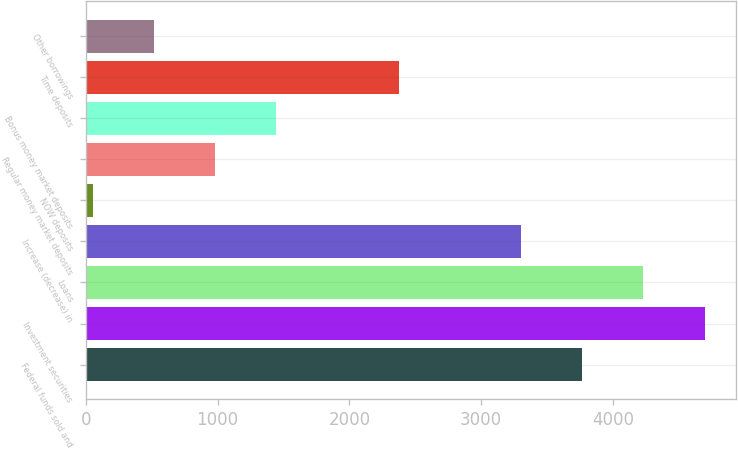Convert chart. <chart><loc_0><loc_0><loc_500><loc_500><bar_chart><fcel>Federal funds sold and<fcel>Investment securities<fcel>Loans<fcel>Increase (decrease) in<fcel>NOW deposits<fcel>Regular money market deposits<fcel>Bonus money market deposits<fcel>Time deposits<fcel>Other borrowings<nl><fcel>3767.2<fcel>4696<fcel>4231.6<fcel>3302.8<fcel>52<fcel>980.8<fcel>1445.2<fcel>2374<fcel>516.4<nl></chart> 